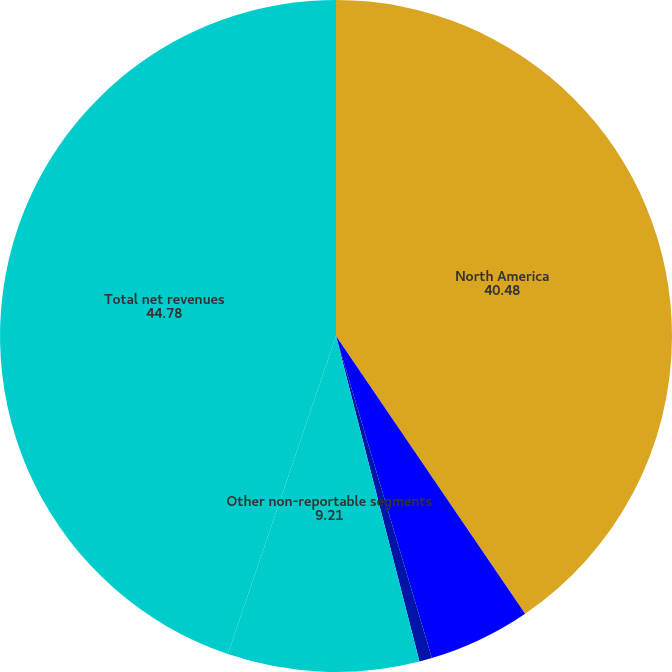Convert chart to OTSL. <chart><loc_0><loc_0><loc_500><loc_500><pie_chart><fcel>North America<fcel>Europe<fcel>Asia<fcel>Other non-reportable segments<fcel>Total net revenues<nl><fcel>40.48%<fcel>4.91%<fcel>0.61%<fcel>9.21%<fcel>44.78%<nl></chart> 